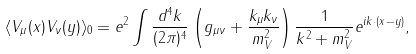Convert formula to latex. <formula><loc_0><loc_0><loc_500><loc_500>\langle V _ { \mu } ( x ) V _ { \nu } ( y ) \rangle _ { 0 } = e ^ { 2 } \int \frac { d ^ { 4 } k } { ( 2 \pi ) ^ { 4 } } \left ( g _ { \mu \nu } + \frac { k _ { \mu } k _ { \nu } } { m _ { V } ^ { 2 } } \right ) \frac { 1 } { k ^ { 2 } + m _ { V } ^ { 2 } } e ^ { i k \cdot ( x - y ) } ,</formula> 